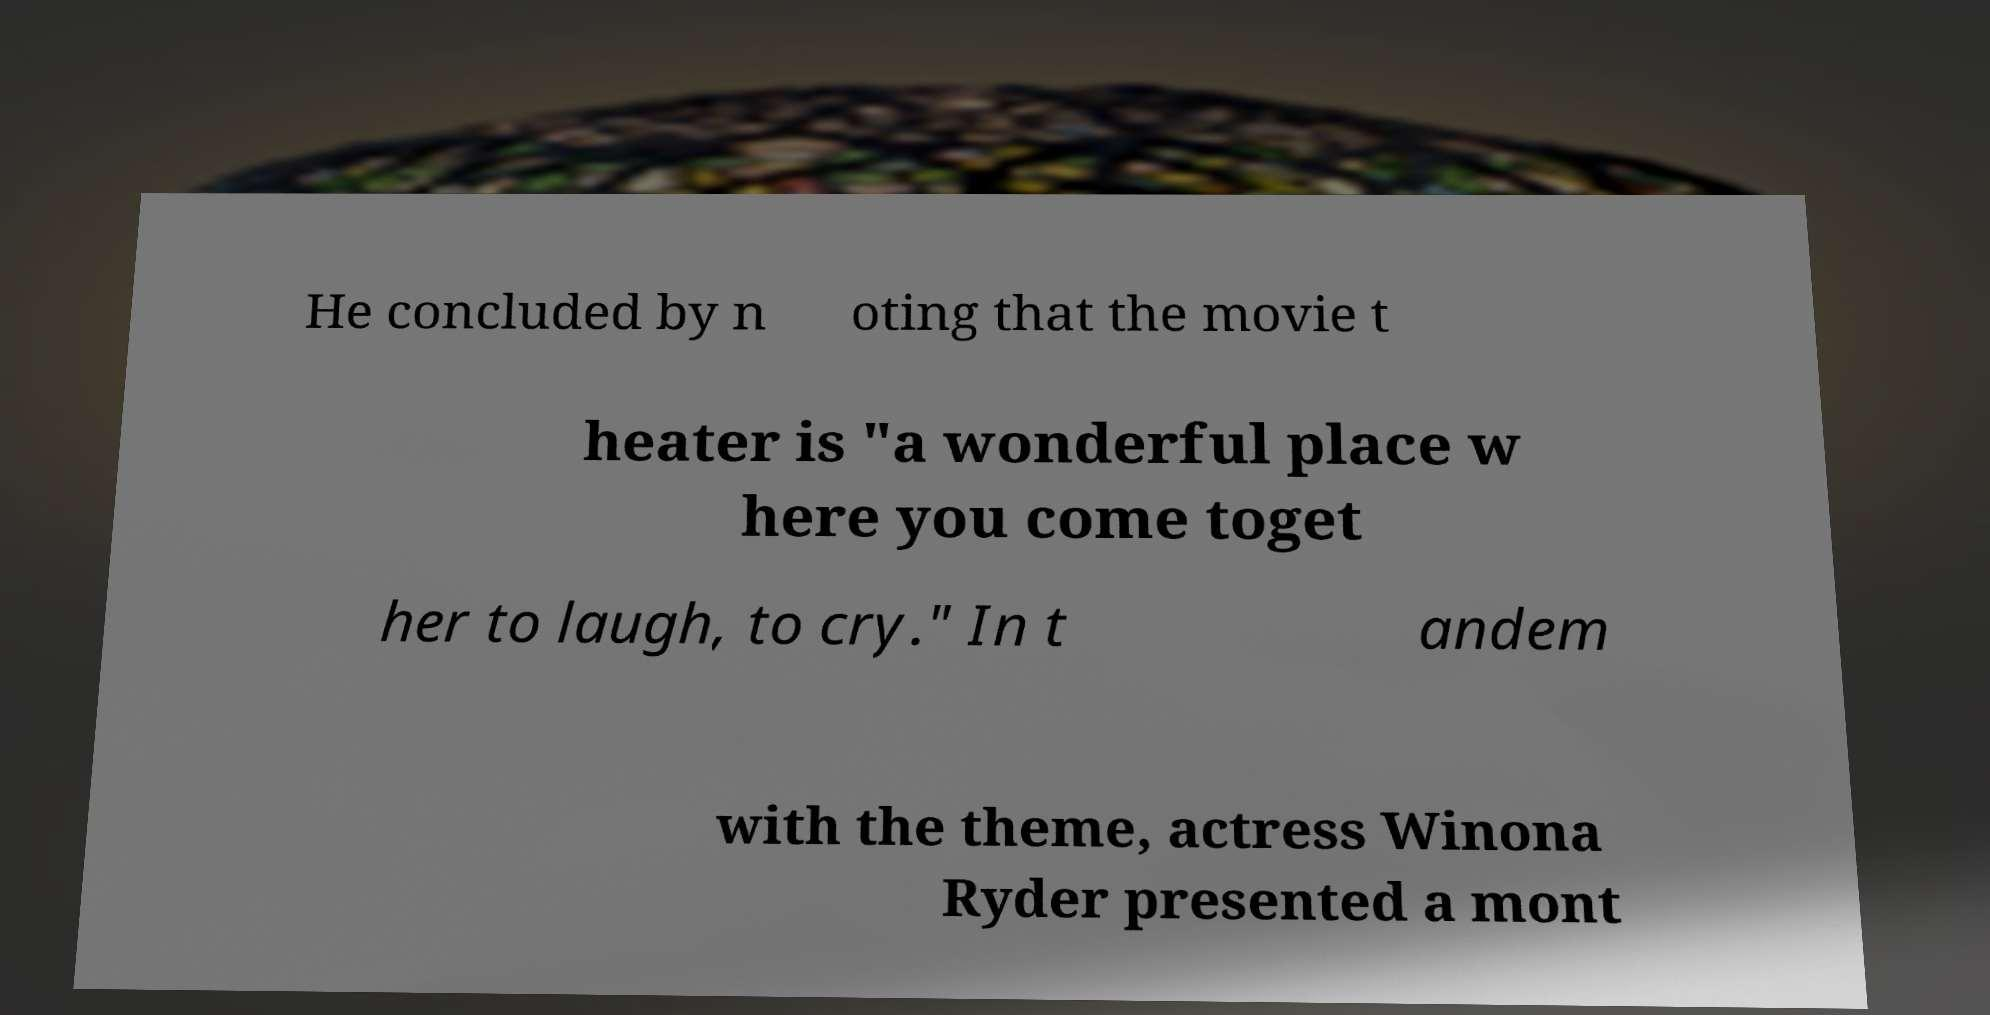Please read and relay the text visible in this image. What does it say? He concluded by n oting that the movie t heater is "a wonderful place w here you come toget her to laugh, to cry." In t andem with the theme, actress Winona Ryder presented a mont 